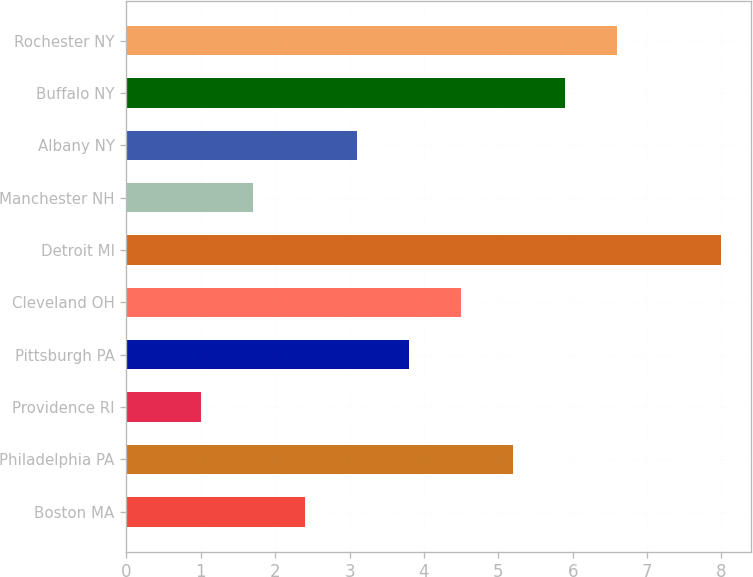<chart> <loc_0><loc_0><loc_500><loc_500><bar_chart><fcel>Boston MA<fcel>Philadelphia PA<fcel>Providence RI<fcel>Pittsburgh PA<fcel>Cleveland OH<fcel>Detroit MI<fcel>Manchester NH<fcel>Albany NY<fcel>Buffalo NY<fcel>Rochester NY<nl><fcel>2.4<fcel>5.2<fcel>1<fcel>3.8<fcel>4.5<fcel>8<fcel>1.7<fcel>3.1<fcel>5.9<fcel>6.6<nl></chart> 